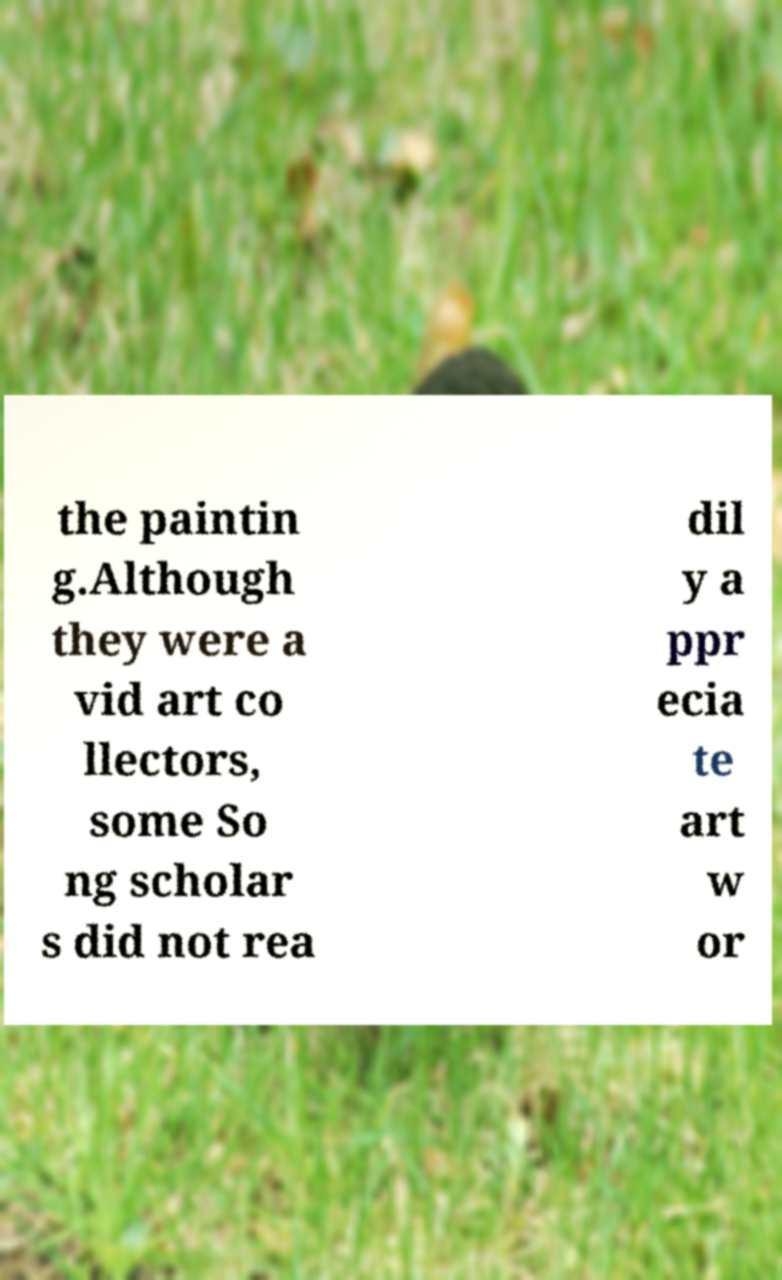Please identify and transcribe the text found in this image. the paintin g.Although they were a vid art co llectors, some So ng scholar s did not rea dil y a ppr ecia te art w or 